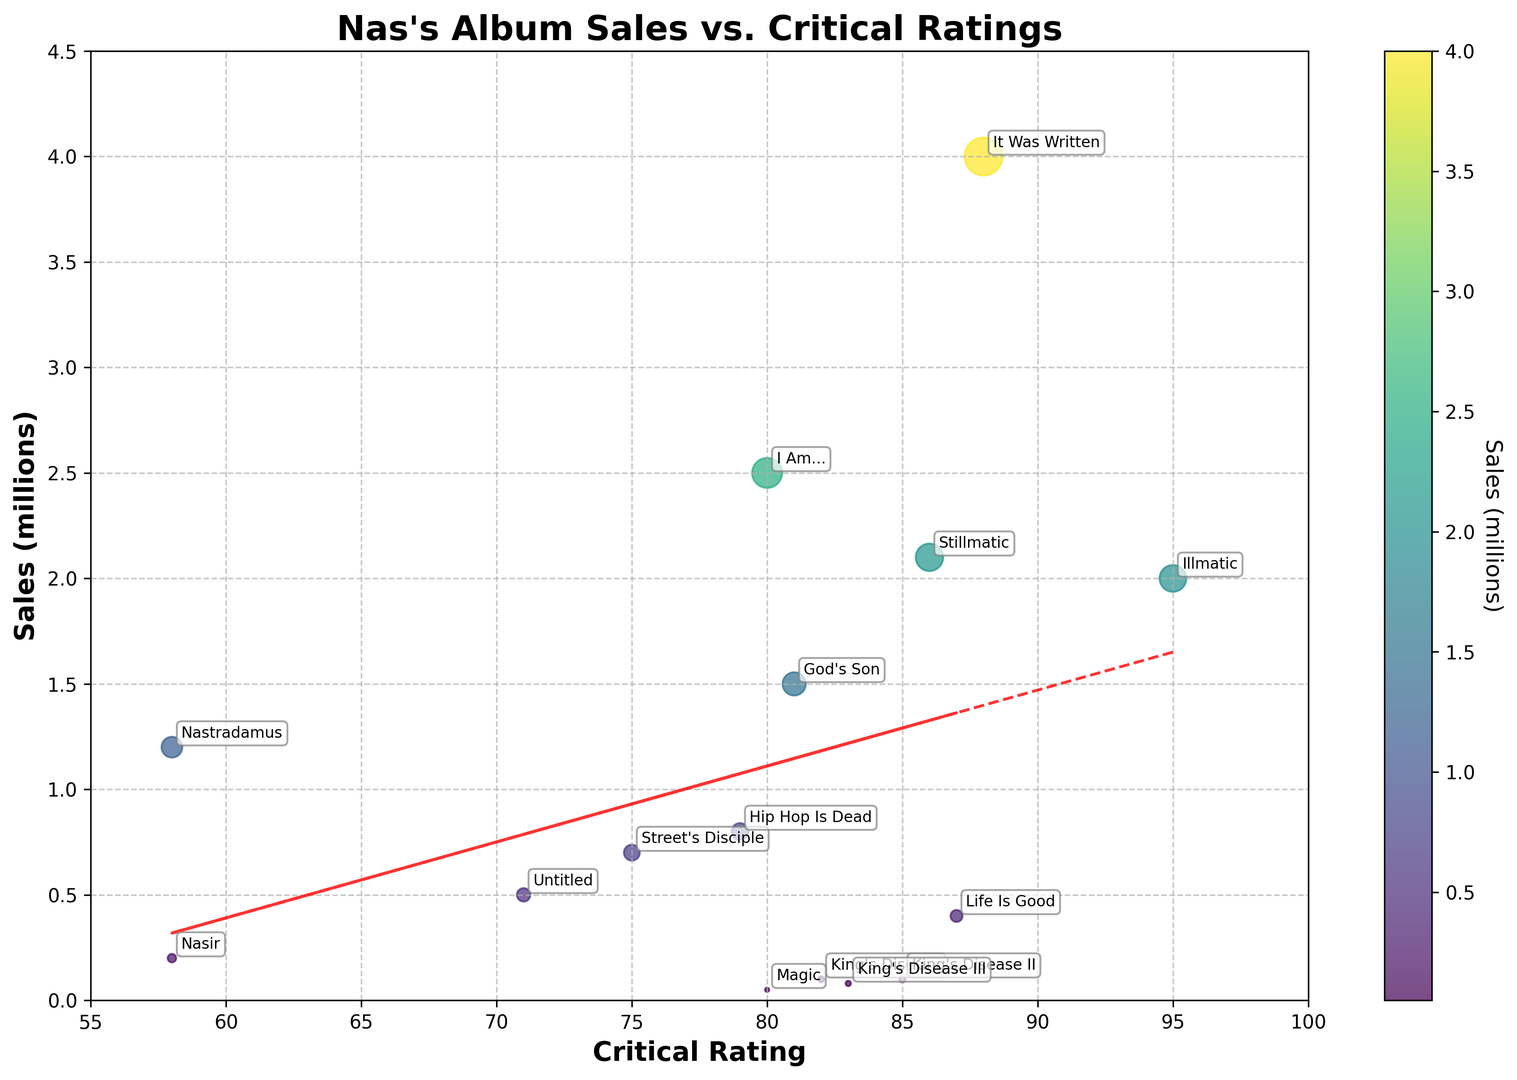Which album has the highest sales? By looking at the bubbles' sizes and positions, the largest bubble is 'It Was Written' with a sales value of 4.0 million copies.
Answer: 'It Was Written' Which album received the highest critical rating? By inspecting the x-axis which represents critical ratings, the furthest right bubble is 'Illmatic' with a rating of 95.
Answer: 'Illmatic' What's the difference in sales between the albums 'Stillmatic' and 'It Was Written'? 'Stillmatic' has 2.1 million sales, and 'It Was Written' has 4.0 million sales. The difference is 4.0 - 2.1 = 1.9.
Answer: 1.9 million How many albums have a critical rating greater than 85? Observing the x-axis where critical ratings are plotted, we count the albums whose ratings are greater than 85: 'Illmatic', 'It Was Written', 'Stillmatic', 'Life Is Good', and 'King's Disease II'—resulting in 5 albums.
Answer: 5 Do higher critical ratings always correlate with higher sales for Nas's albums? Although 'Illmatic' has the highest rating, it does not have the highest sales. 'It Was Written' has lower ratings but the highest sales, indicating that critical ratings do not consistently correlate with higher sales.
Answer: No Which album with the lowest sales has a critical rating above 80? Checking the lower sales bubbles, 'Magic' with a sales value of 0.05 million has a rating of 80.
Answer: 'Magic' Which album has the least critical rating, and what is its sales amount? The album 'Nastradamus' shows the lowest rating of 58 and has sales of 1.2 million.
Answer: 'Nastradamus', 1.2 million What is the color indication for the album with the highest rating? The color of the bubble representing 'Illmatic' (highest rating) should be checked, and it is generally darker as it is shaded with 'viridis' color map related to a lower sales figure (2.0 million).
Answer: Dark (lower sales shading) What is the range of sales values across all of Nas's albums? Observing the y-axis for the sales values, the smallest sales is 'Magic' with 0.05 million, and the largest is 'It Was Written' with 4.0 million, giving a range of 4 - 0.05 = 3.95.
Answer: 3.95 million Which album has the closest sales figure to 2 million but is less than this value? 'Illmatic' has sales very close to 2 million but slightly less, at 2.0 million, matching the criterion.
Answer: 'Illmatic' 